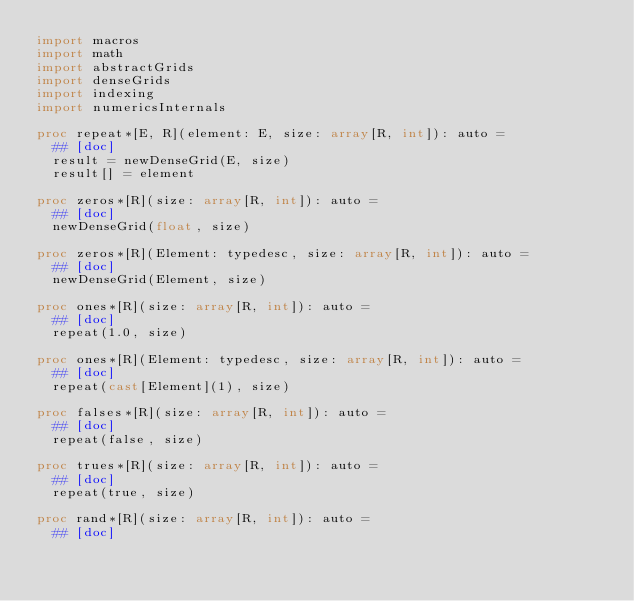Convert code to text. <code><loc_0><loc_0><loc_500><loc_500><_Nim_>import macros
import math
import abstractGrids
import denseGrids
import indexing
import numericsInternals

proc repeat*[E, R](element: E, size: array[R, int]): auto =
  ## [doc]
  result = newDenseGrid(E, size)
  result[] = element

proc zeros*[R](size: array[R, int]): auto =
  ## [doc]
  newDenseGrid(float, size)

proc zeros*[R](Element: typedesc, size: array[R, int]): auto =
  ## [doc]
  newDenseGrid(Element, size)

proc ones*[R](size: array[R, int]): auto =
  ## [doc]
  repeat(1.0, size)

proc ones*[R](Element: typedesc, size: array[R, int]): auto =
  ## [doc]
  repeat(cast[Element](1), size)

proc falses*[R](size: array[R, int]): auto =
  ## [doc]
  repeat(false, size)

proc trues*[R](size: array[R, int]): auto =
  ## [doc]
  repeat(true, size)

proc rand*[R](size: array[R, int]): auto =
  ## [doc]</code> 